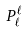<formula> <loc_0><loc_0><loc_500><loc_500>P _ { \ell } ^ { \ell }</formula> 